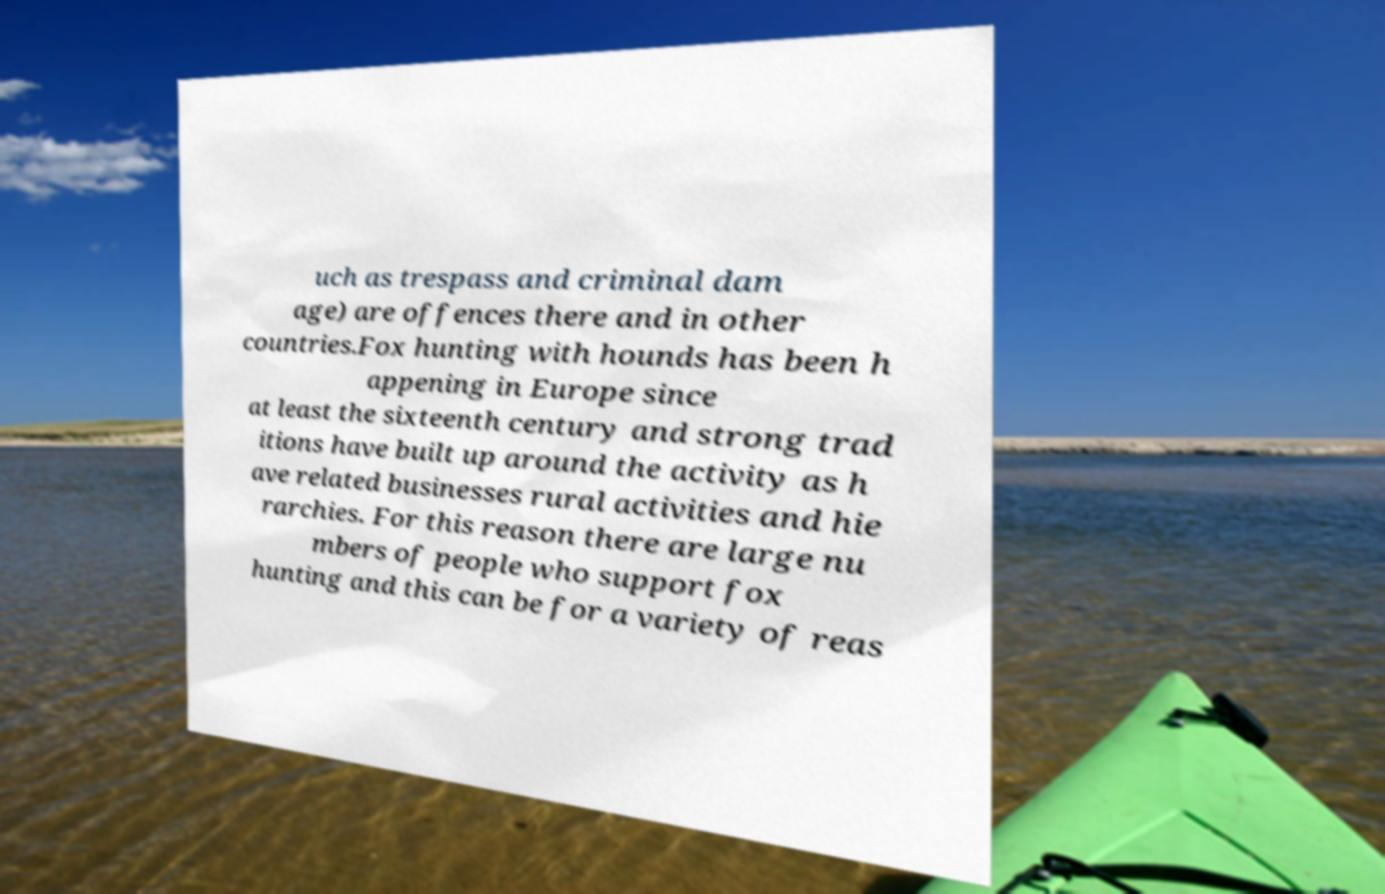Can you accurately transcribe the text from the provided image for me? uch as trespass and criminal dam age) are offences there and in other countries.Fox hunting with hounds has been h appening in Europe since at least the sixteenth century and strong trad itions have built up around the activity as h ave related businesses rural activities and hie rarchies. For this reason there are large nu mbers of people who support fox hunting and this can be for a variety of reas 